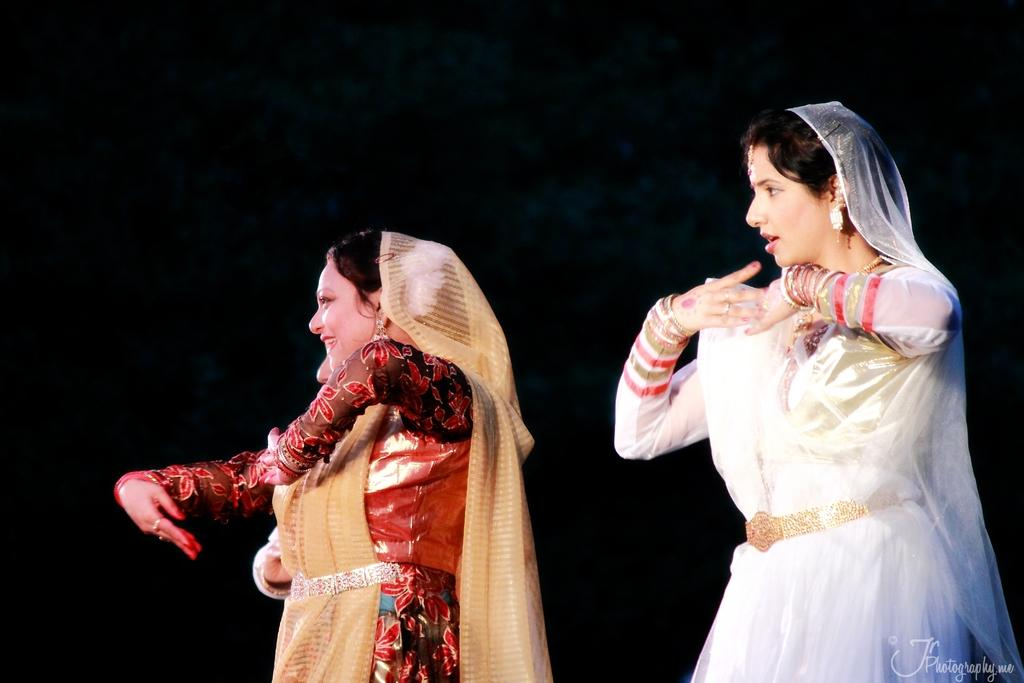How many people are in the image? There are three persons in the image. What are the persons doing in the image? The persons are dancing. What are the persons wearing in the image? The persons are wearing multi-color dresses. What is the color of the background in the image? The background of the image is dark. What type of pie can be seen in the image? There is no pie present in the image. What sound can be heard coming from the loud and clear in the image? The image is a still photograph, so no sound can be heard. 